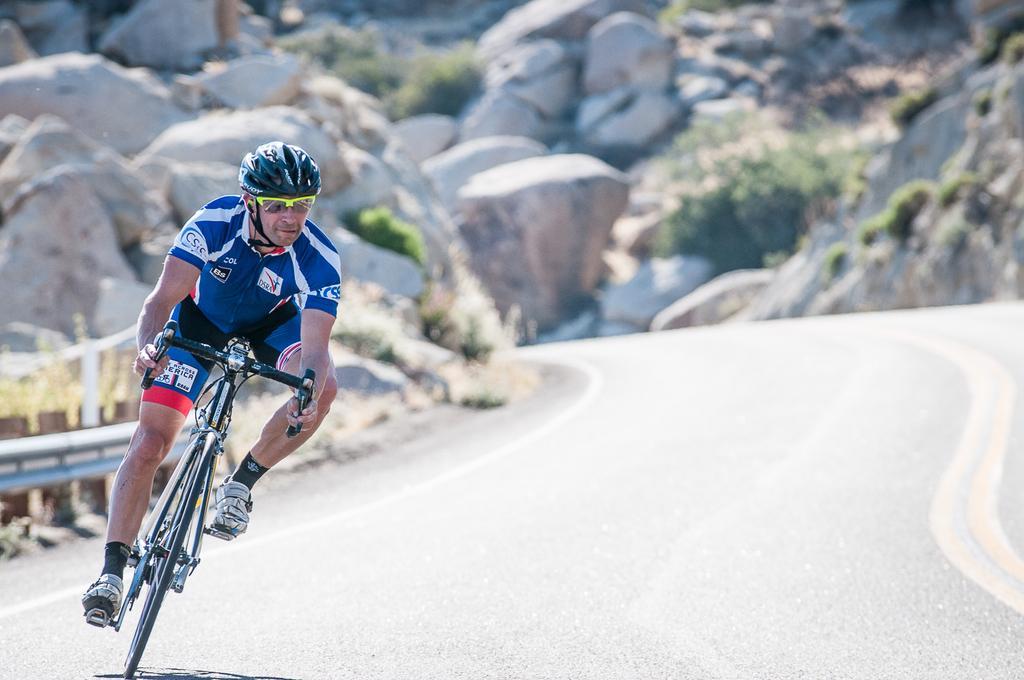How would you summarize this image in a sentence or two? In the image we can see there is a person sitting on bicycle and he is wearing helmet and sun glasses. Behind there are rocks and hills. 